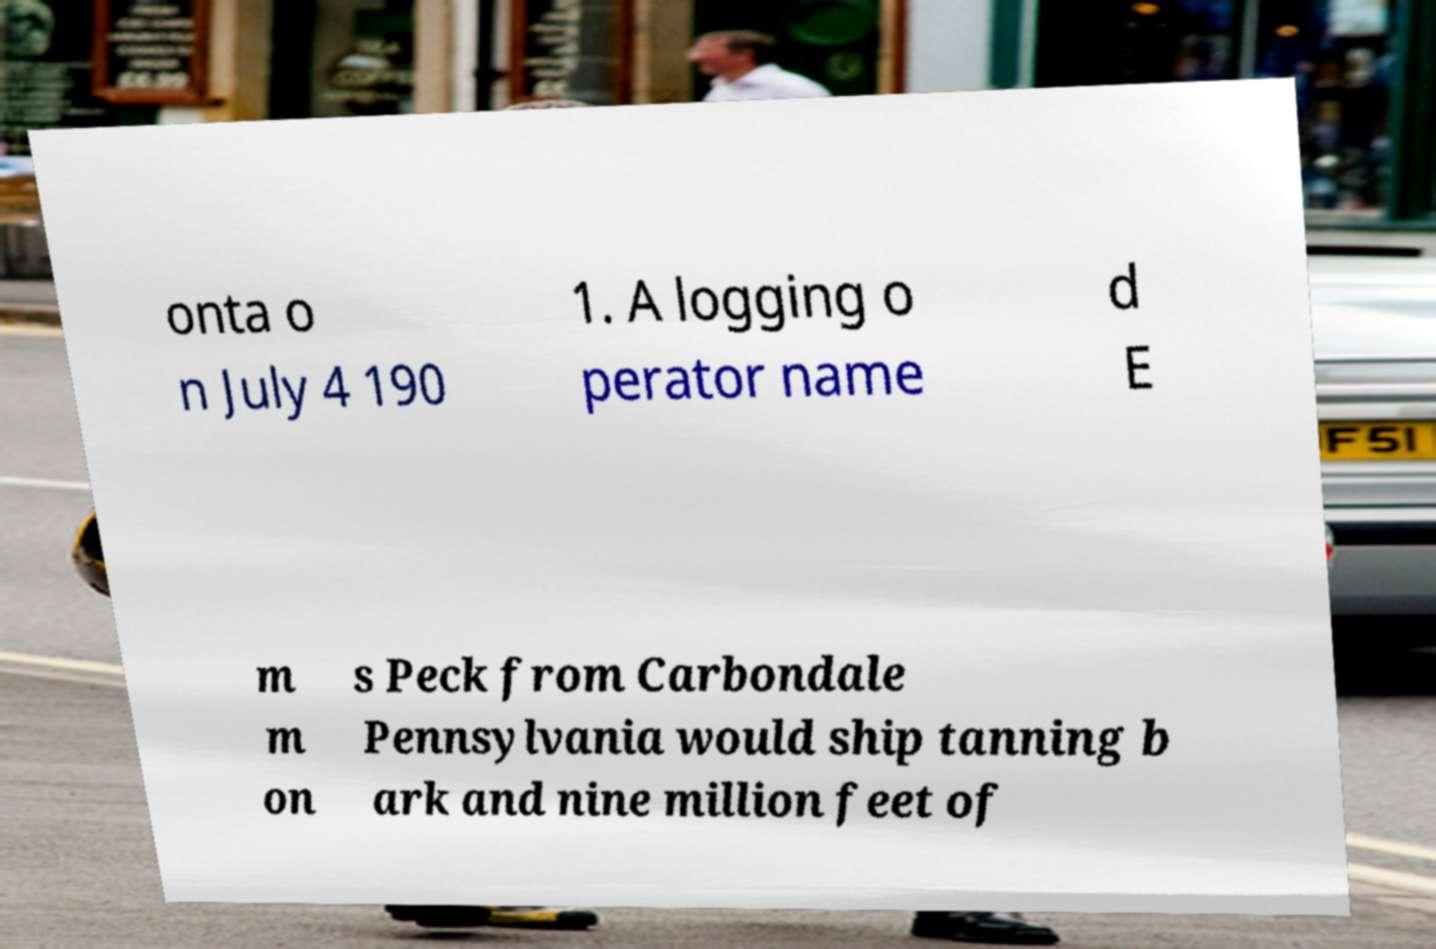Could you extract and type out the text from this image? onta o n July 4 190 1. A logging o perator name d E m m on s Peck from Carbondale Pennsylvania would ship tanning b ark and nine million feet of 